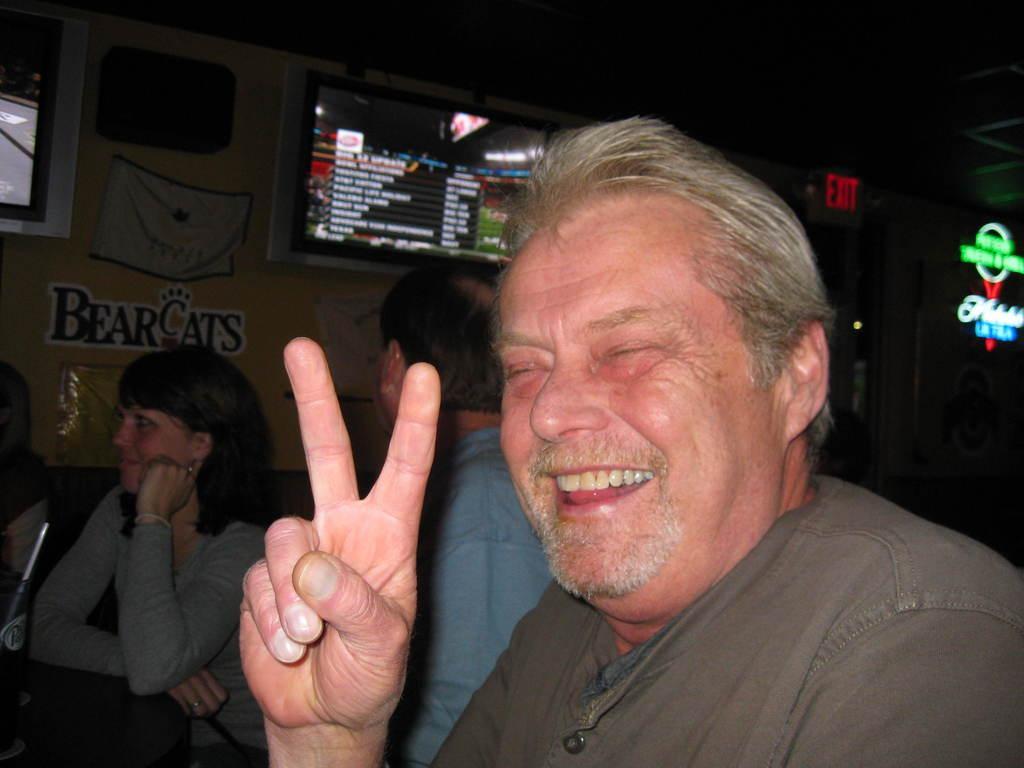In one or two sentences, can you explain what this image depicts? In a club some people are sitting in front of the table and in the front a person is posing for the photo, in the background there is a wall and a screen is kept in front of the wall and the menu is being displayed on the screen, on the right side there is an exit door and beside the door there is a name of the club it is lightened up with the lights. 